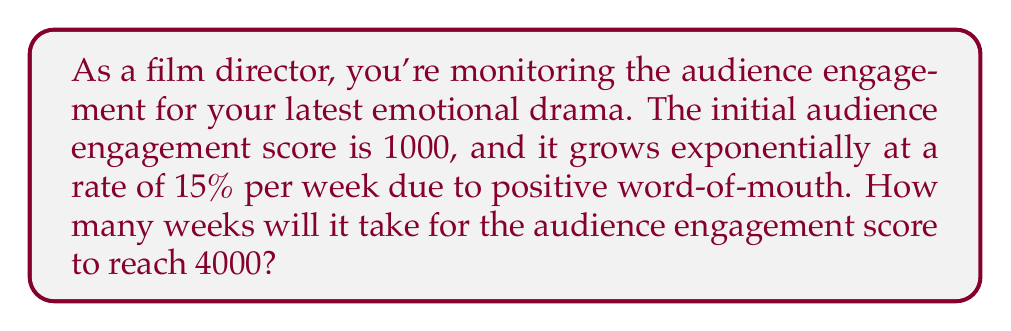Could you help me with this problem? Let's approach this step-by-step using an exponential function:

1) The exponential function for this scenario is:
   $A(t) = 1000(1.15)^t$
   Where $A(t)$ is the audience engagement score after $t$ weeks.

2) We want to find $t$ when $A(t) = 4000$. So, we set up the equation:
   $4000 = 1000(1.15)^t$

3) Divide both sides by 1000:
   $4 = (1.15)^t$

4) Take the natural log of both sides:
   $\ln(4) = \ln((1.15)^t)$

5) Use the logarithm property $\ln(a^b) = b\ln(a)$:
   $\ln(4) = t\ln(1.15)$

6) Solve for $t$:
   $t = \frac{\ln(4)}{\ln(1.15)}$

7) Calculate:
   $t \approx 9.6297$ weeks

8) Since we can't have a fractional week, we round up to the nearest whole week.
Answer: 10 weeks 